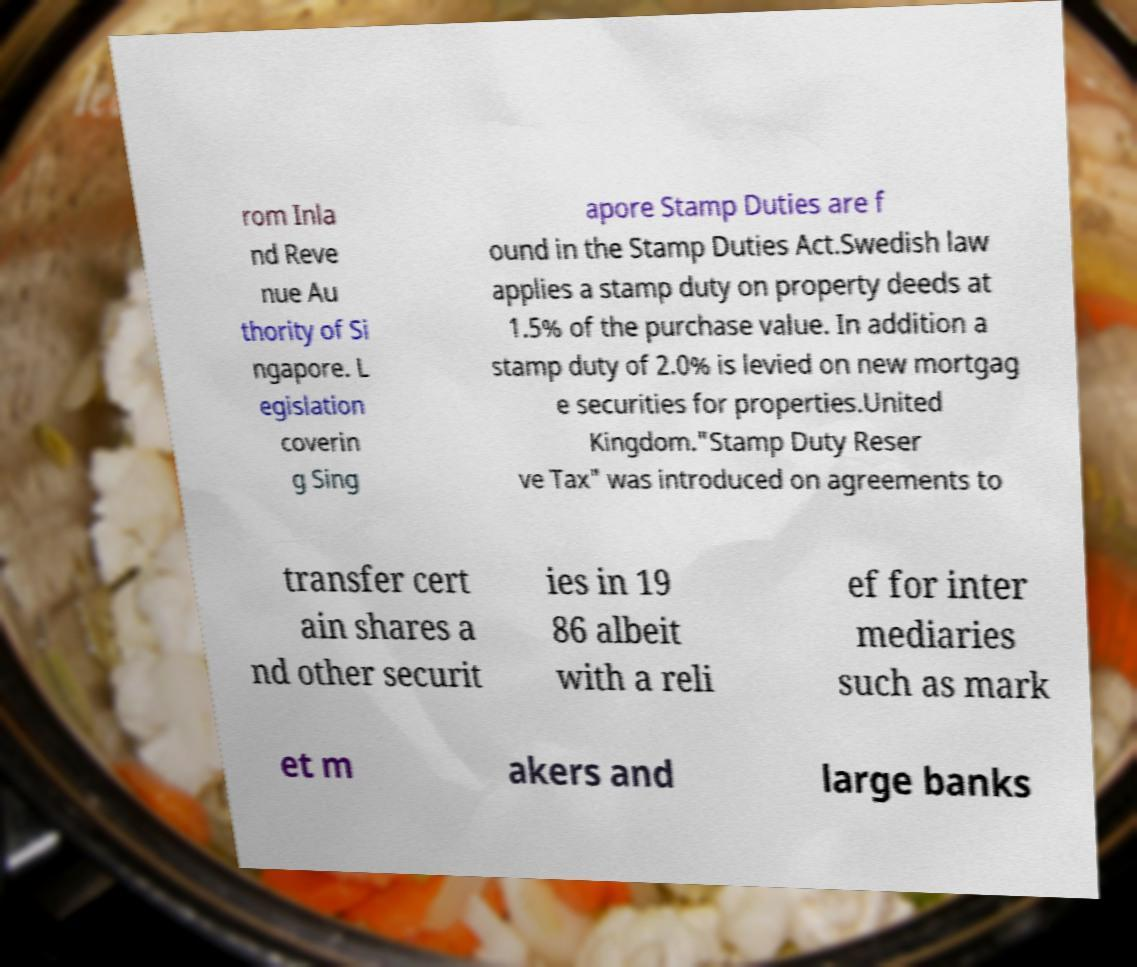Can you accurately transcribe the text from the provided image for me? rom Inla nd Reve nue Au thority of Si ngapore. L egislation coverin g Sing apore Stamp Duties are f ound in the Stamp Duties Act.Swedish law applies a stamp duty on property deeds at 1.5% of the purchase value. In addition a stamp duty of 2.0% is levied on new mortgag e securities for properties.United Kingdom."Stamp Duty Reser ve Tax" was introduced on agreements to transfer cert ain shares a nd other securit ies in 19 86 albeit with a reli ef for inter mediaries such as mark et m akers and large banks 